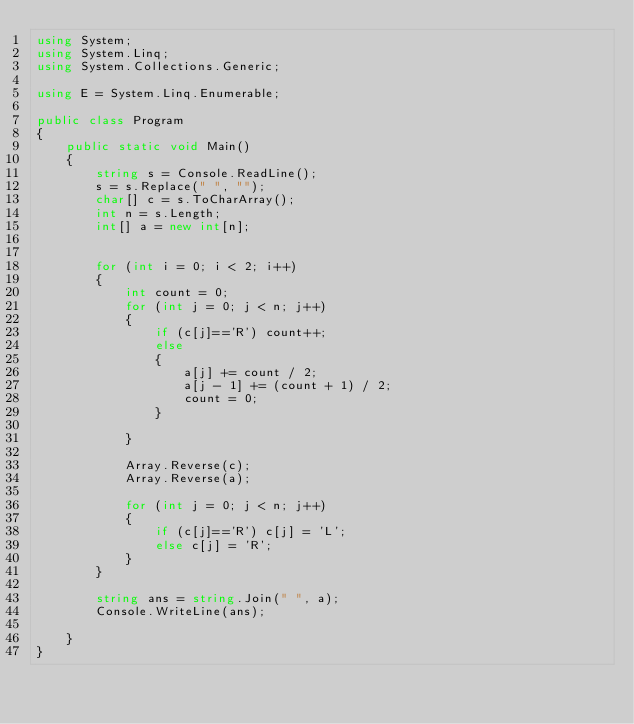Convert code to text. <code><loc_0><loc_0><loc_500><loc_500><_C#_>using System;
using System.Linq;
using System.Collections.Generic;

using E = System.Linq.Enumerable;

public class Program
{
    public static void Main()
    {
        string s = Console.ReadLine();
        s = s.Replace(" ", "");
        char[] c = s.ToCharArray();
        int n = s.Length;
        int[] a = new int[n];


        for (int i = 0; i < 2; i++)
        {
            int count = 0;
            for (int j = 0; j < n; j++)
            {
                if (c[j]=='R') count++;
                else
                {
                    a[j] += count / 2;
                    a[j - 1] += (count + 1) / 2;
                    count = 0;
                }
                
            }

            Array.Reverse(c);
            Array.Reverse(a);

            for (int j = 0; j < n; j++)
            {
                if (c[j]=='R') c[j] = 'L';
                else c[j] = 'R';
            }
        }

        string ans = string.Join(" ", a);
        Console.WriteLine(ans);

    }
}</code> 